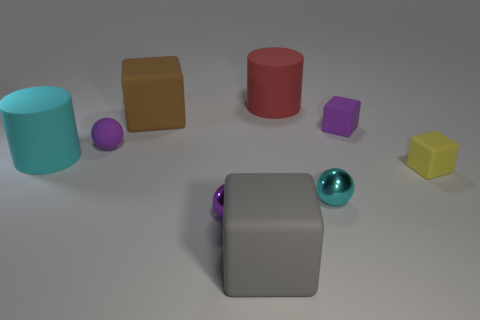Subtract 1 blocks. How many blocks are left? 3 Subtract all purple cubes. How many cubes are left? 3 Subtract all tiny purple blocks. How many blocks are left? 3 Subtract all green cubes. Subtract all purple spheres. How many cubes are left? 4 Add 1 matte balls. How many objects exist? 10 Subtract all cubes. How many objects are left? 5 Add 3 matte cylinders. How many matte cylinders exist? 5 Subtract 0 red blocks. How many objects are left? 9 Subtract all large purple metallic things. Subtract all cyan shiny spheres. How many objects are left? 8 Add 7 tiny shiny balls. How many tiny shiny balls are left? 9 